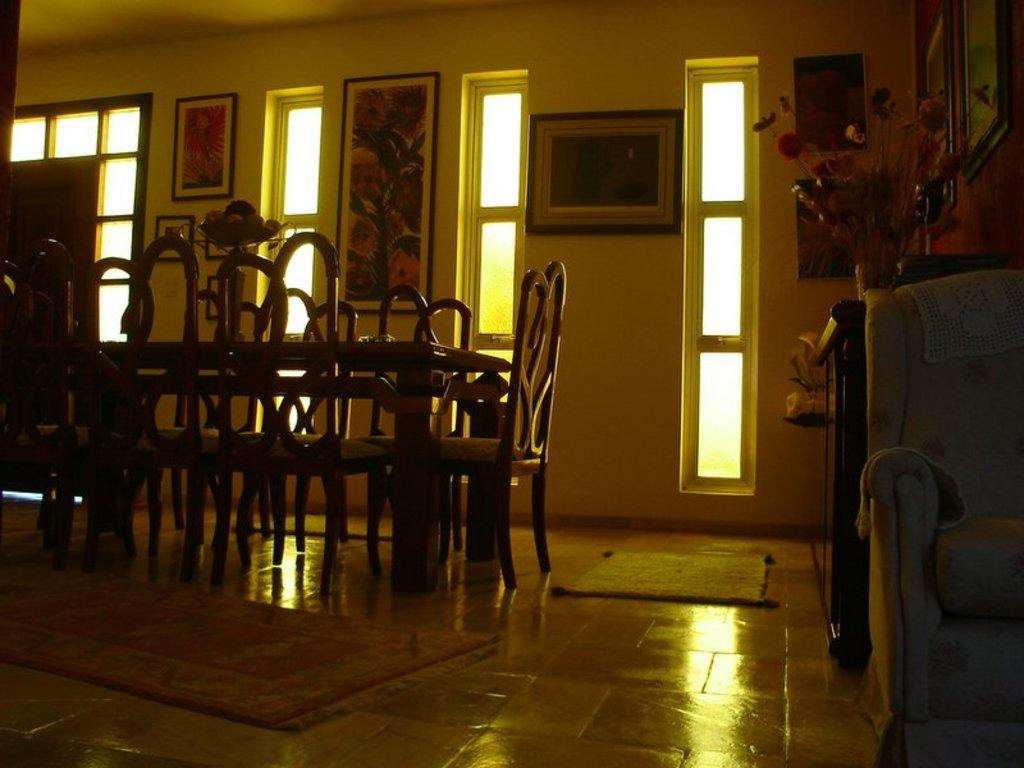What type of furniture is present in the image? There are chairs, a table, and a cupboard in the image. What decorative item can be seen in the image? There is an artificial plant in the image. What is attached to the wall in the image? There are frames attached to the wall in the image. What type of floor covering is present in the image? There are mats in the image. What type of soup is being served in the image? There is no soup present in the image. How does the wing of the bird in the image help it fly? There is no bird or wing present in the image. 